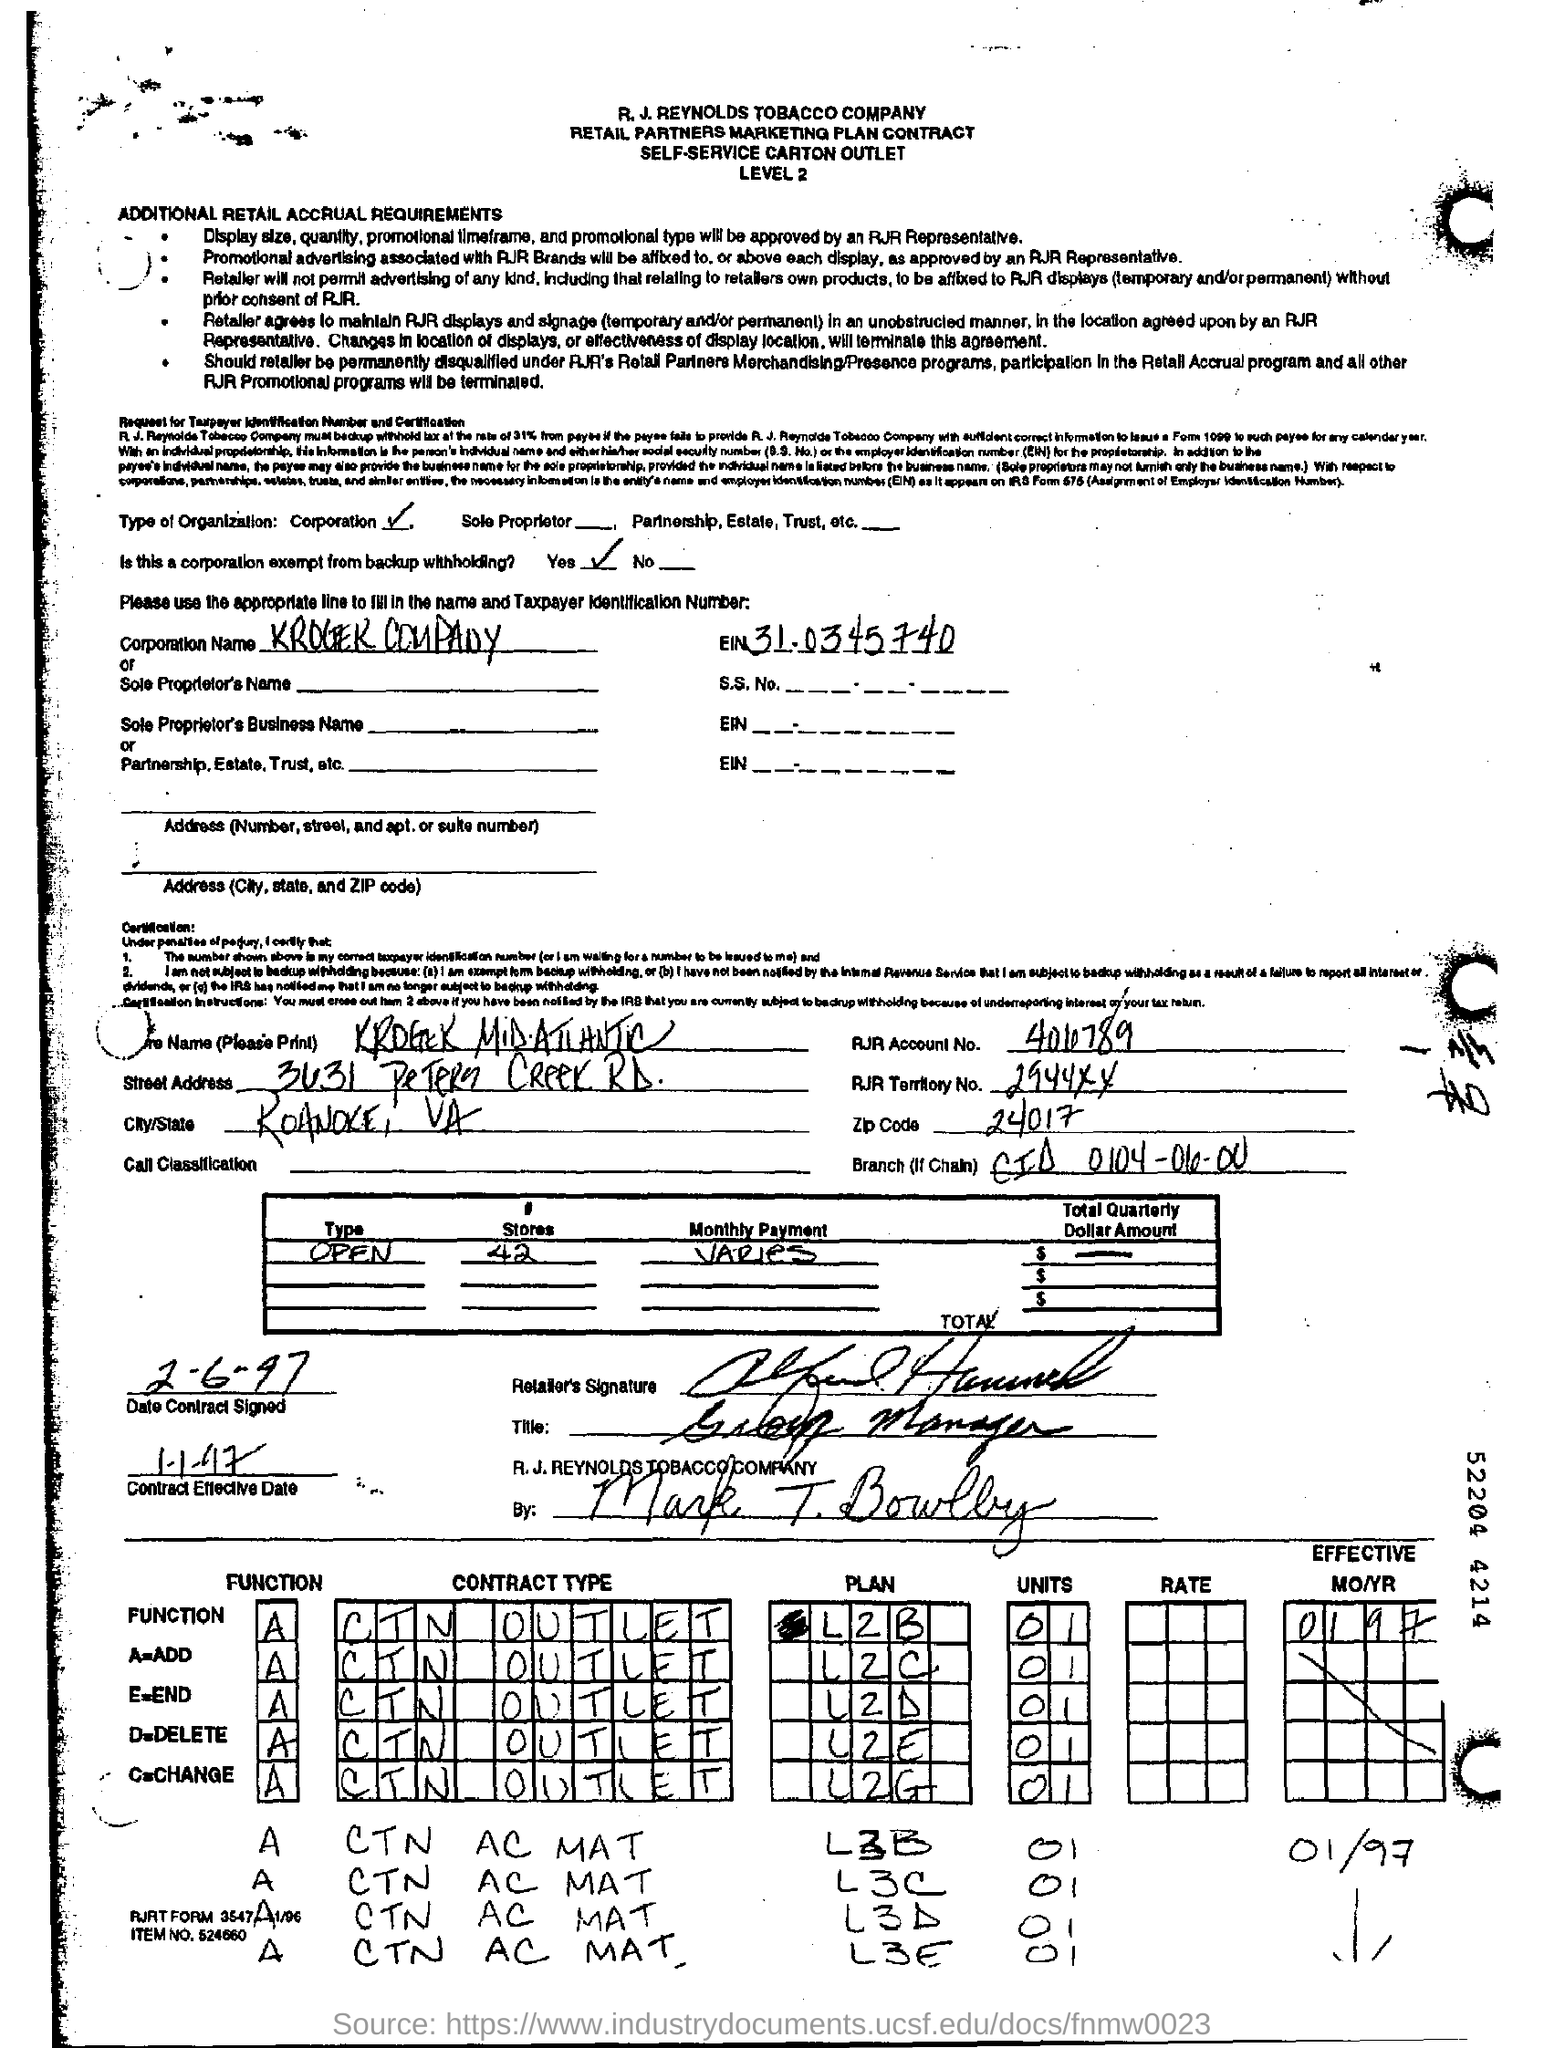Mention the type of organization ?
Offer a terse response. Corporation. Is this a corporation exempt from backup withholding ?
Provide a succinct answer. Yes. What is the zipcode ?
Your response must be concise. 24017. How many #stores are there ?
Your answer should be compact. 42. Mention the contract effective date ?
Your answer should be very brief. 1-1-97. What is the item no. ?
Make the answer very short. 524660. What is the function a=?
Your answer should be very brief. Add. What is the function d=?
Give a very brief answer. Delete. 